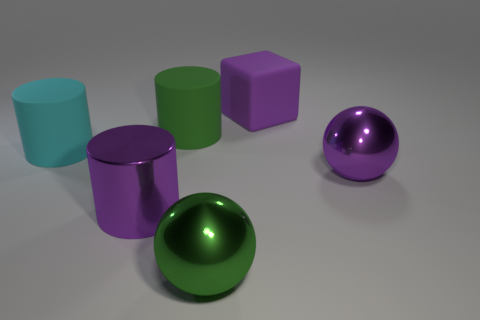What shape is the big purple thing that is both to the right of the big green rubber object and in front of the block?
Keep it short and to the point. Sphere. How many objects are either purple cubes or big things behind the large green shiny sphere?
Ensure brevity in your answer.  5. There is another large thing that is the same shape as the big green metal thing; what material is it?
Ensure brevity in your answer.  Metal. What is the material of the thing that is on the right side of the large green shiny ball and in front of the big matte cube?
Provide a short and direct response. Metal. How many other things are the same shape as the large cyan object?
Keep it short and to the point. 2. There is a cube on the left side of the purple metal thing that is behind the big purple cylinder; what is its color?
Offer a very short reply. Purple. Are there the same number of large purple metal objects that are behind the large purple matte cube and tiny matte blocks?
Make the answer very short. Yes. Is there a metallic cylinder of the same size as the purple shiny ball?
Offer a terse response. Yes. There is a purple metallic cylinder; does it have the same size as the thing that is right of the big purple rubber thing?
Your answer should be very brief. Yes. Are there an equal number of green objects left of the green matte cylinder and green objects that are behind the big cyan object?
Your answer should be very brief. No. 